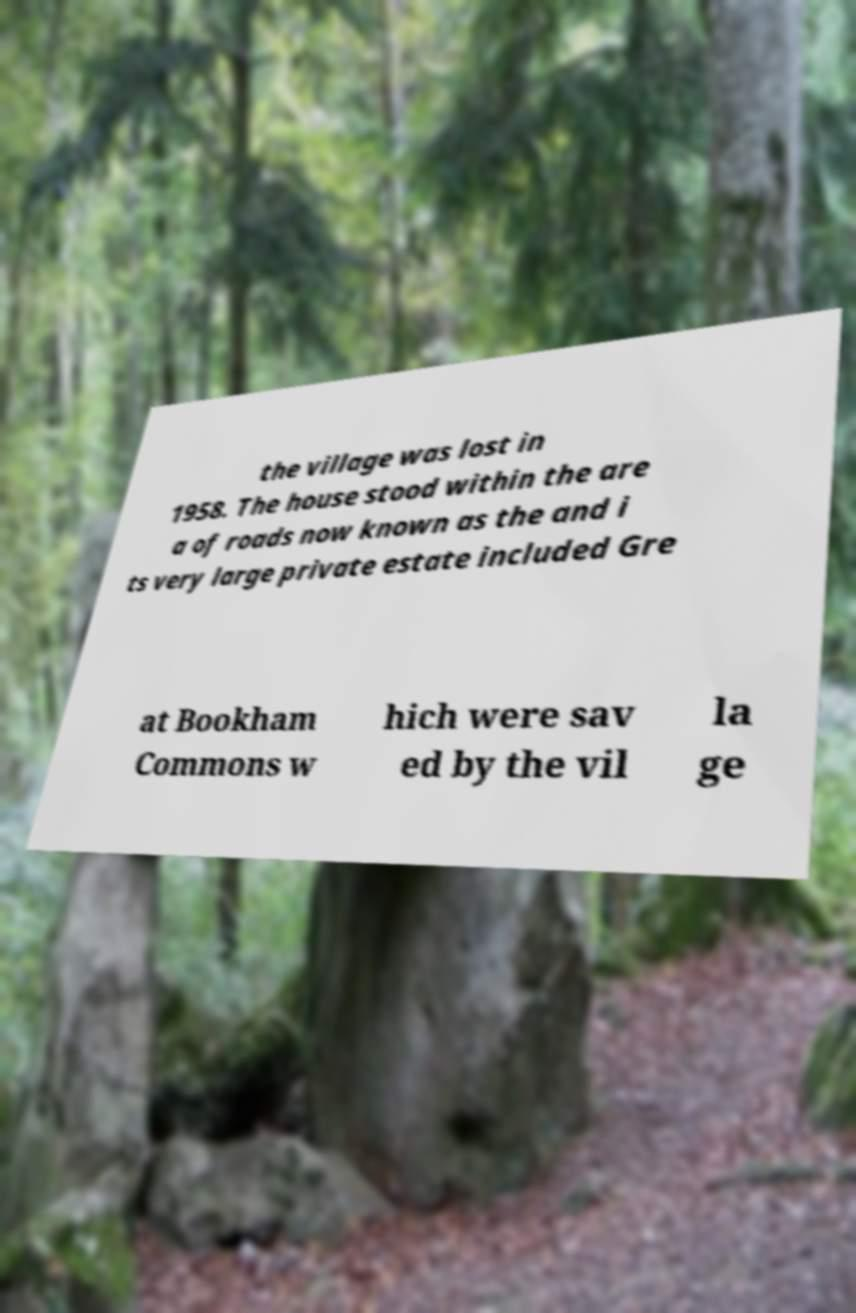Can you accurately transcribe the text from the provided image for me? the village was lost in 1958. The house stood within the are a of roads now known as the and i ts very large private estate included Gre at Bookham Commons w hich were sav ed by the vil la ge 